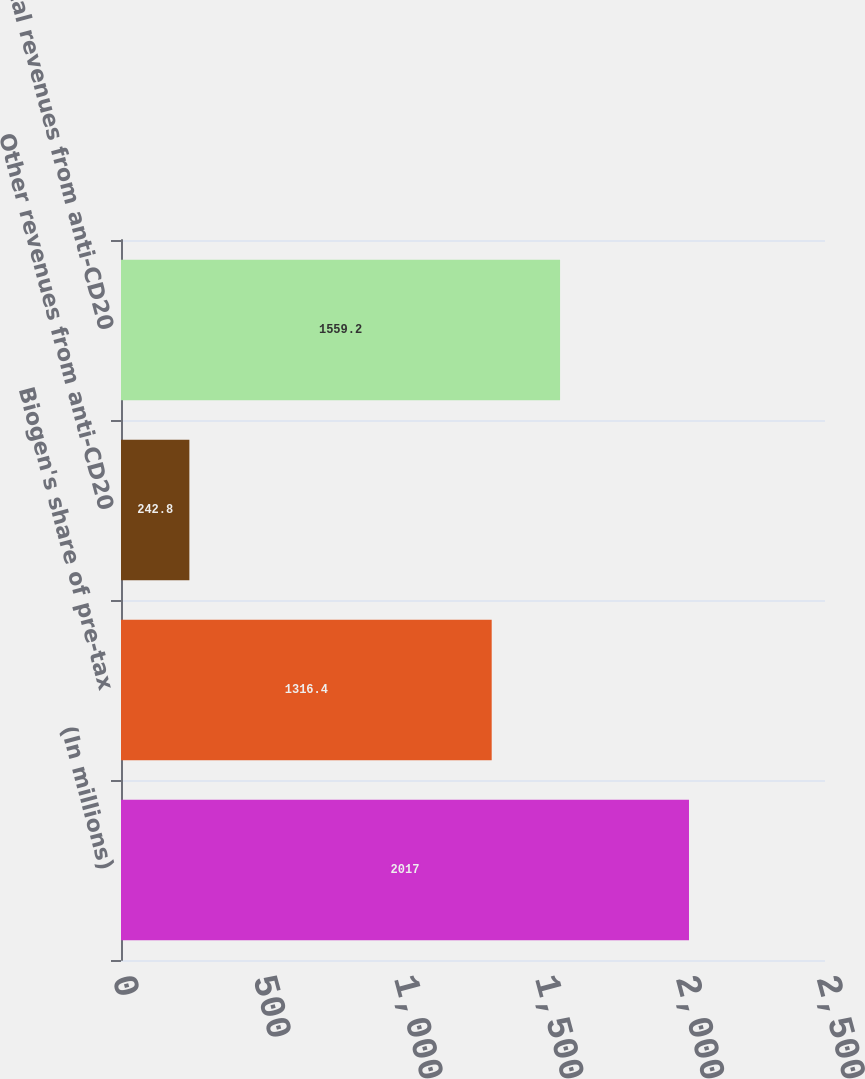Convert chart. <chart><loc_0><loc_0><loc_500><loc_500><bar_chart><fcel>(In millions)<fcel>Biogen's share of pre-tax<fcel>Other revenues from anti-CD20<fcel>Total revenues from anti-CD20<nl><fcel>2017<fcel>1316.4<fcel>242.8<fcel>1559.2<nl></chart> 